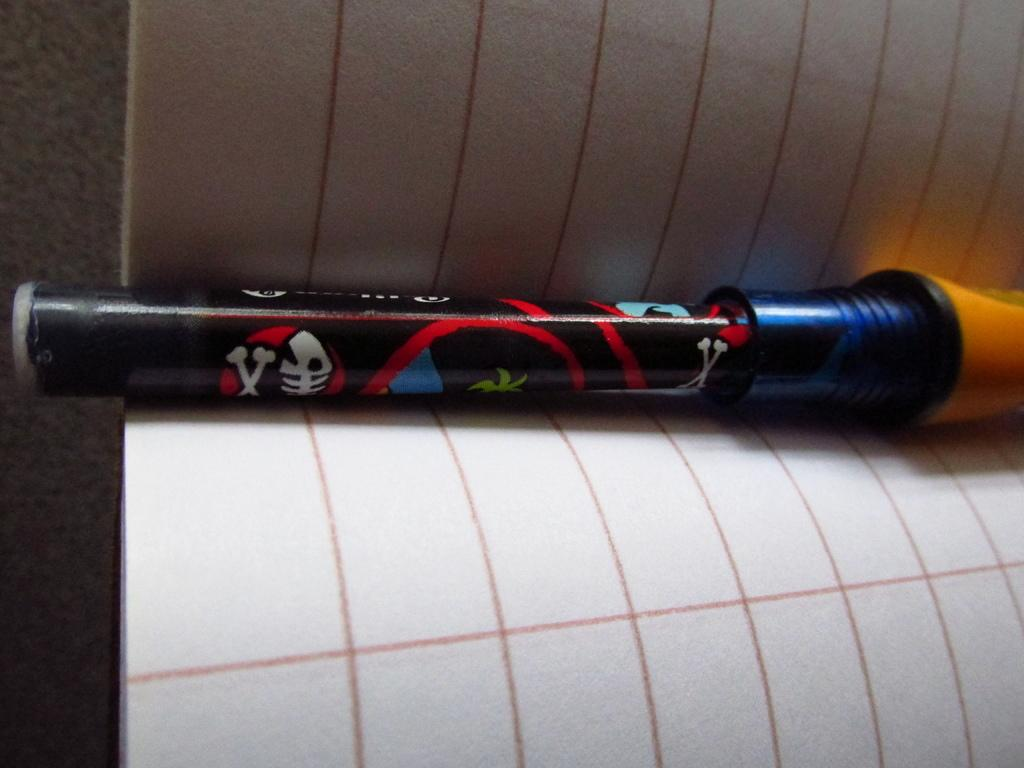What object is in the middle of the book in the image? There is a marker in the middle of the book in the image. Where is the book located in the image? The book is in the foreground of the image. What type of brass instrument is being played in the background of the image? There is no brass instrument or background music present in the image; it only features a marker in the middle of a book. 